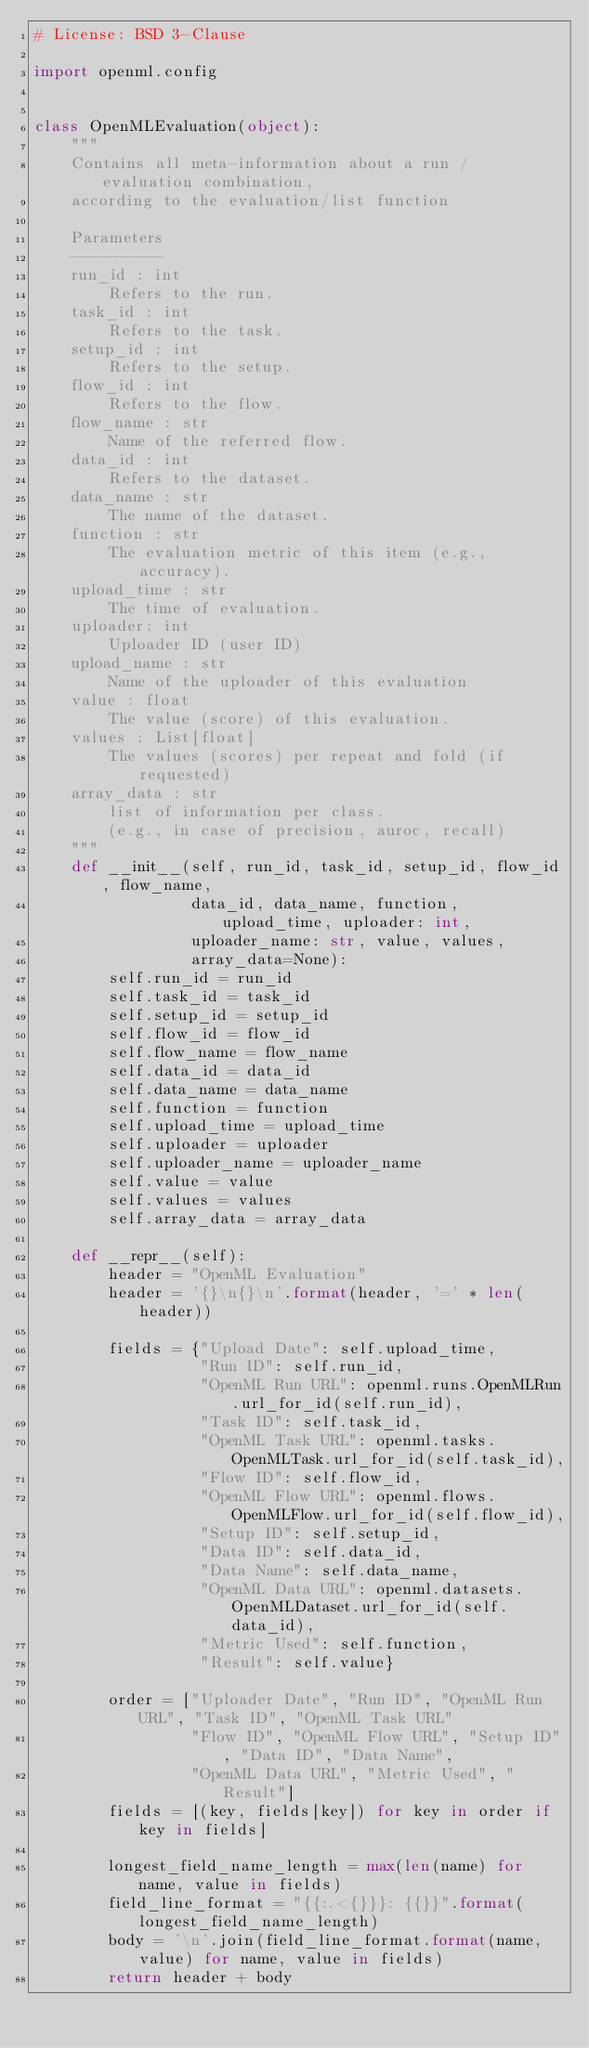Convert code to text. <code><loc_0><loc_0><loc_500><loc_500><_Python_># License: BSD 3-Clause

import openml.config


class OpenMLEvaluation(object):
    """
    Contains all meta-information about a run / evaluation combination,
    according to the evaluation/list function

    Parameters
    ----------
    run_id : int
        Refers to the run.
    task_id : int
        Refers to the task.
    setup_id : int
        Refers to the setup.
    flow_id : int
        Refers to the flow.
    flow_name : str
        Name of the referred flow.
    data_id : int
        Refers to the dataset.
    data_name : str
        The name of the dataset.
    function : str
        The evaluation metric of this item (e.g., accuracy).
    upload_time : str
        The time of evaluation.
    uploader: int
        Uploader ID (user ID)
    upload_name : str
        Name of the uploader of this evaluation
    value : float
        The value (score) of this evaluation.
    values : List[float]
        The values (scores) per repeat and fold (if requested)
    array_data : str
        list of information per class.
        (e.g., in case of precision, auroc, recall)
    """
    def __init__(self, run_id, task_id, setup_id, flow_id, flow_name,
                 data_id, data_name, function, upload_time, uploader: int,
                 uploader_name: str, value, values,
                 array_data=None):
        self.run_id = run_id
        self.task_id = task_id
        self.setup_id = setup_id
        self.flow_id = flow_id
        self.flow_name = flow_name
        self.data_id = data_id
        self.data_name = data_name
        self.function = function
        self.upload_time = upload_time
        self.uploader = uploader
        self.uploader_name = uploader_name
        self.value = value
        self.values = values
        self.array_data = array_data

    def __repr__(self):
        header = "OpenML Evaluation"
        header = '{}\n{}\n'.format(header, '=' * len(header))

        fields = {"Upload Date": self.upload_time,
                  "Run ID": self.run_id,
                  "OpenML Run URL": openml.runs.OpenMLRun.url_for_id(self.run_id),
                  "Task ID": self.task_id,
                  "OpenML Task URL": openml.tasks.OpenMLTask.url_for_id(self.task_id),
                  "Flow ID": self.flow_id,
                  "OpenML Flow URL": openml.flows.OpenMLFlow.url_for_id(self.flow_id),
                  "Setup ID": self.setup_id,
                  "Data ID": self.data_id,
                  "Data Name": self.data_name,
                  "OpenML Data URL": openml.datasets.OpenMLDataset.url_for_id(self.data_id),
                  "Metric Used": self.function,
                  "Result": self.value}

        order = ["Uploader Date", "Run ID", "OpenML Run URL", "Task ID", "OpenML Task URL"
                 "Flow ID", "OpenML Flow URL", "Setup ID", "Data ID", "Data Name",
                 "OpenML Data URL", "Metric Used", "Result"]
        fields = [(key, fields[key]) for key in order if key in fields]

        longest_field_name_length = max(len(name) for name, value in fields)
        field_line_format = "{{:.<{}}}: {{}}".format(longest_field_name_length)
        body = '\n'.join(field_line_format.format(name, value) for name, value in fields)
        return header + body
</code> 